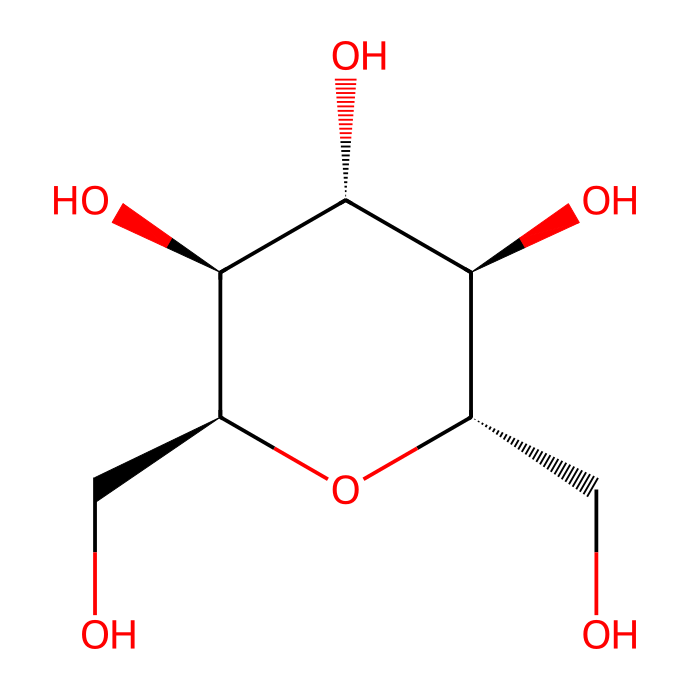How many carbon atoms are in the structure? By analyzing the SMILES notation, we can count the carbon atoms denoted by "C". There are a total of six "C" symbols before we reach the end of the chain, indicating there are six carbon atoms.
Answer: six What type of bonding is primarily seen in this structure? The SMILES notation represents a polyol structure with multiple -OH groups. The presence of these hydroxyl groups indicates that this molecule predominantly exhibits hydrogen bonding.
Answer: hydrogen bonding How many hydroxyl (-OH) groups are present in the structure? In the provided structure, we can identify and count the -OH groups (hydroxyl groups). From the notation, there are four -OH groups attached to the structure.
Answer: four What functional group characterizes this compound as a carbohydrate? The multiple hydroxyl (-OH) groups present throughout the structure indicate that this molecule has the characteristics of a carbohydrate, which typically contains these specific functional groups.
Answer: hydroxyl What kind of Non-Newtonian behavior does cornstarch exhibit? Cornstarch behaves as a shear-thickening fluid under stress, meaning that as shear forces increase, its viscosity increases significantly, which is often described in Non-Newtonian fluid behavior.
Answer: shear-thickening What is the largest ring present in this starch structure? By analyzing the structure closely, we can identify that there is a five-membered ring indicated by the portion where carbon atoms bond in a cyclic manner. Thus, the largest ring structure is a pentose.
Answer: pentose How does the branching structure of cornstarch affect its viscosity? The branching structure of starch contributes to its ability to form viscous gels under certain conditions, as it increases interaction points among molecules, resulting in a higher viscosity.
Answer: increases viscosity 